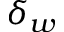<formula> <loc_0><loc_0><loc_500><loc_500>\delta _ { w }</formula> 